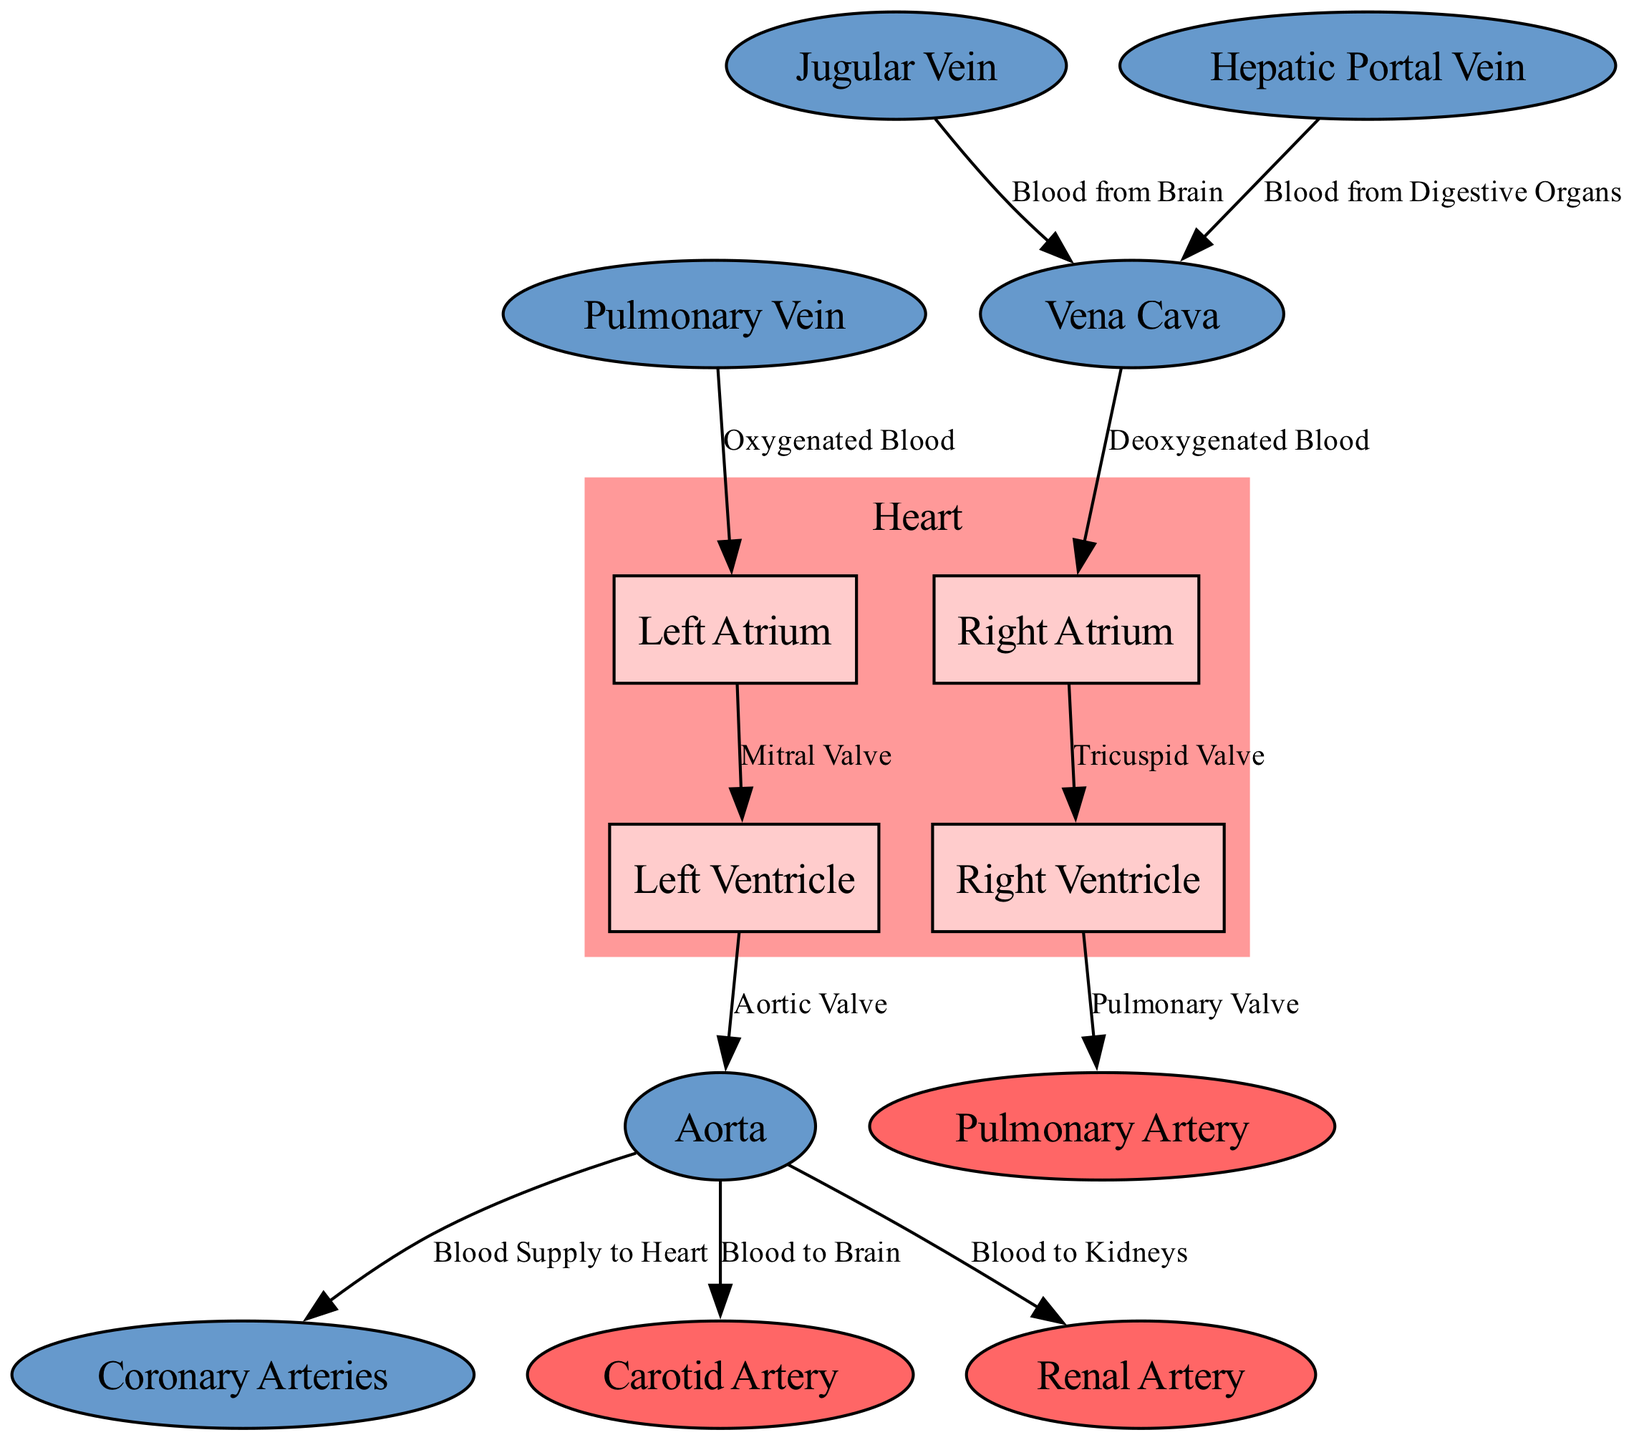What are the four chambers of the heart? The diagram clearly shows the four chambers of the heart: Right Atrium, Right Ventricle, Left Atrium, and Left Ventricle.
Answer: Right Atrium, Right Ventricle, Left Atrium, Left Ventricle What valve is between the Right Atrium and Right Ventricle? Looking at the edge connecting the Right Atrium (ra) and Right Ventricle (rv), the label indicates that it is the Tricuspid Valve.
Answer: Tricuspid Valve How many main veins are labeled in the diagram? Counting the nodes, there are three main veins labeled: Vena Cava, Pulmonary Vein, and Jugular Vein.
Answer: Three What artery carries blood from the heart to the lungs? The diagram shows an edge from the Right Ventricle to the Pulmonary Artery, which is labeled as carrying blood to the lungs.
Answer: Pulmonary Artery Which vessels bring oxygenated blood to the heart? The diagram indicates that the Pulmonary Vein is the vessel that brings oxygenated blood to the Left Atrium from the lungs.
Answer: Pulmonary Vein What supplies the heart with blood? The edge labeled “Blood Supply to Heart” connects the Aorta to the Coronary Arteries, indicating that the Coronary Arteries provide blood to the heart.
Answer: Coronary Arteries From which organ does the Hepatic Portal Vein carry blood? The label on the Hepatic Portal Vein signifies that it carries blood from the Digestive Organs to the Vena Cava.
Answer: Digestive Organs What is the function of the Aortic Valve? The Aortic Valve is depicted as regulating the flow of blood from the Left Ventricle into the Aorta, ensuring one-way blood flow.
Answer: Regulating Blood Flow Which artery supplies the brain? Following the diagram, blood from the Aorta goes to the Carotid Artery, which supplies the brain.
Answer: Carotid Artery 